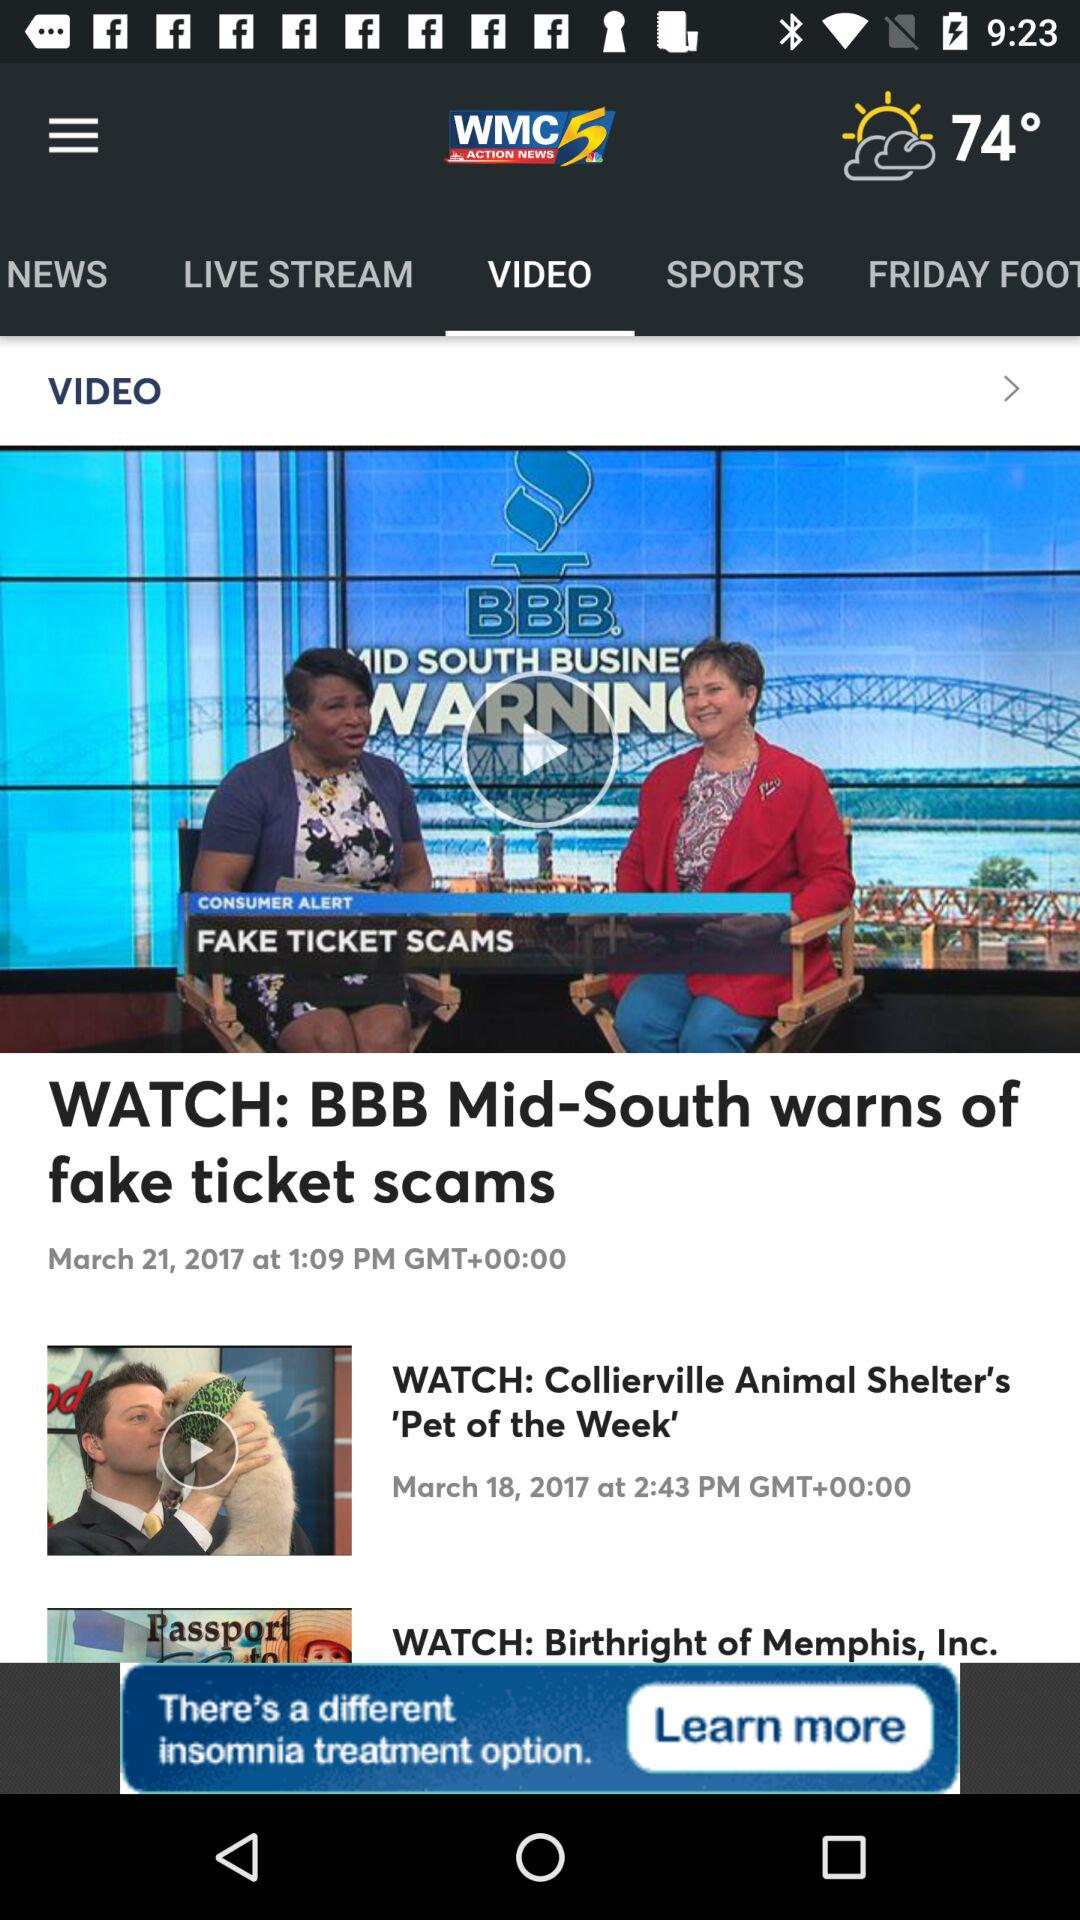What is the date of the BBB Mid-South warns of fake ticket scams show? The date of the BBB Mid-South warns of fake ticket scams show is March 21, 2017. 